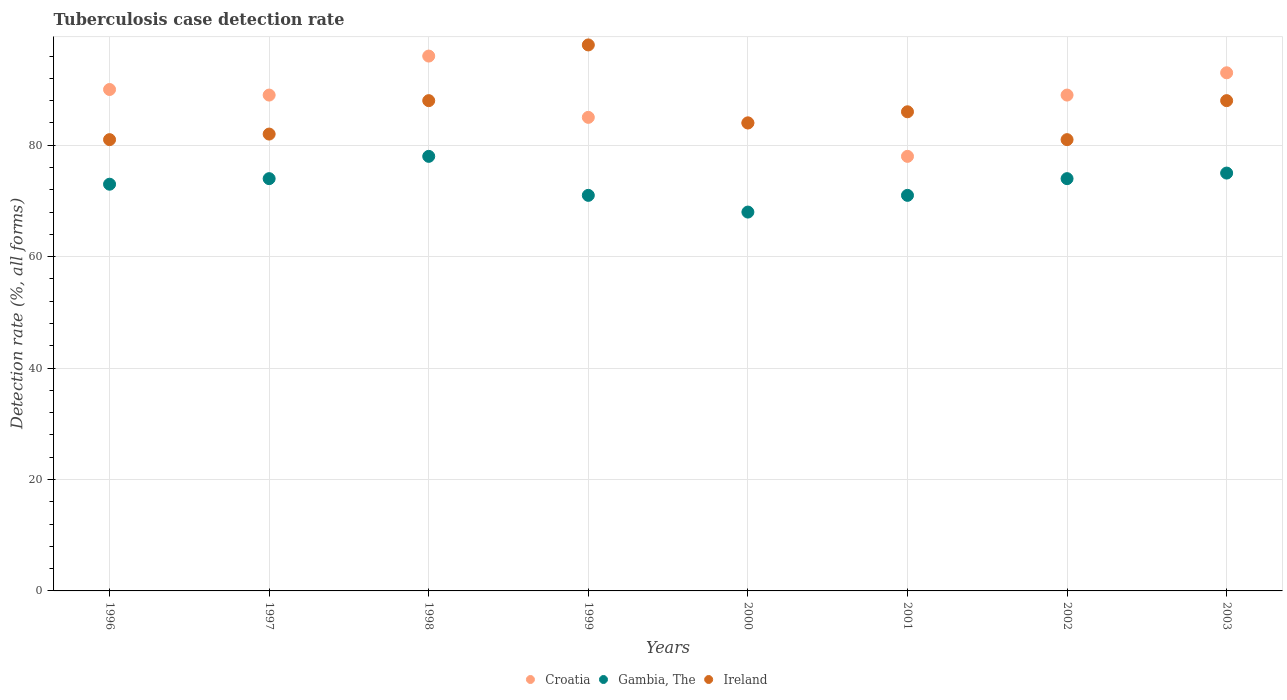Is the number of dotlines equal to the number of legend labels?
Provide a short and direct response. Yes. What is the tuberculosis case detection rate in in Gambia, The in 2000?
Ensure brevity in your answer.  68. Across all years, what is the maximum tuberculosis case detection rate in in Ireland?
Offer a very short reply. 98. Across all years, what is the minimum tuberculosis case detection rate in in Ireland?
Ensure brevity in your answer.  81. In which year was the tuberculosis case detection rate in in Croatia maximum?
Your answer should be compact. 1998. What is the total tuberculosis case detection rate in in Gambia, The in the graph?
Keep it short and to the point. 584. What is the difference between the tuberculosis case detection rate in in Ireland in 1998 and that in 2001?
Your answer should be compact. 2. What is the difference between the tuberculosis case detection rate in in Ireland in 1999 and the tuberculosis case detection rate in in Croatia in 2000?
Your answer should be very brief. 14. What is the average tuberculosis case detection rate in in Gambia, The per year?
Offer a terse response. 73. In the year 1998, what is the difference between the tuberculosis case detection rate in in Croatia and tuberculosis case detection rate in in Gambia, The?
Ensure brevity in your answer.  18. In how many years, is the tuberculosis case detection rate in in Ireland greater than 80 %?
Ensure brevity in your answer.  8. What is the ratio of the tuberculosis case detection rate in in Croatia in 1999 to that in 2002?
Make the answer very short. 0.96. Is the tuberculosis case detection rate in in Croatia in 1999 less than that in 2003?
Keep it short and to the point. Yes. In how many years, is the tuberculosis case detection rate in in Croatia greater than the average tuberculosis case detection rate in in Croatia taken over all years?
Provide a succinct answer. 5. Is the sum of the tuberculosis case detection rate in in Ireland in 1996 and 1999 greater than the maximum tuberculosis case detection rate in in Croatia across all years?
Your answer should be compact. Yes. What is the difference between two consecutive major ticks on the Y-axis?
Ensure brevity in your answer.  20. Are the values on the major ticks of Y-axis written in scientific E-notation?
Offer a terse response. No. Does the graph contain grids?
Offer a very short reply. Yes. Where does the legend appear in the graph?
Ensure brevity in your answer.  Bottom center. How many legend labels are there?
Offer a terse response. 3. What is the title of the graph?
Give a very brief answer. Tuberculosis case detection rate. Does "Brunei Darussalam" appear as one of the legend labels in the graph?
Give a very brief answer. No. What is the label or title of the X-axis?
Keep it short and to the point. Years. What is the label or title of the Y-axis?
Keep it short and to the point. Detection rate (%, all forms). What is the Detection rate (%, all forms) of Ireland in 1996?
Give a very brief answer. 81. What is the Detection rate (%, all forms) of Croatia in 1997?
Keep it short and to the point. 89. What is the Detection rate (%, all forms) of Gambia, The in 1997?
Make the answer very short. 74. What is the Detection rate (%, all forms) in Croatia in 1998?
Your response must be concise. 96. What is the Detection rate (%, all forms) of Gambia, The in 1998?
Make the answer very short. 78. What is the Detection rate (%, all forms) of Gambia, The in 1999?
Provide a short and direct response. 71. What is the Detection rate (%, all forms) in Croatia in 2001?
Ensure brevity in your answer.  78. What is the Detection rate (%, all forms) of Ireland in 2001?
Provide a succinct answer. 86. What is the Detection rate (%, all forms) of Croatia in 2002?
Your answer should be compact. 89. What is the Detection rate (%, all forms) in Ireland in 2002?
Ensure brevity in your answer.  81. What is the Detection rate (%, all forms) of Croatia in 2003?
Offer a terse response. 93. What is the Detection rate (%, all forms) of Ireland in 2003?
Your answer should be compact. 88. Across all years, what is the maximum Detection rate (%, all forms) of Croatia?
Your answer should be compact. 96. Across all years, what is the maximum Detection rate (%, all forms) of Gambia, The?
Keep it short and to the point. 78. Across all years, what is the maximum Detection rate (%, all forms) in Ireland?
Your answer should be very brief. 98. Across all years, what is the minimum Detection rate (%, all forms) of Gambia, The?
Your response must be concise. 68. What is the total Detection rate (%, all forms) in Croatia in the graph?
Keep it short and to the point. 704. What is the total Detection rate (%, all forms) of Gambia, The in the graph?
Ensure brevity in your answer.  584. What is the total Detection rate (%, all forms) of Ireland in the graph?
Provide a short and direct response. 688. What is the difference between the Detection rate (%, all forms) in Ireland in 1996 and that in 1998?
Ensure brevity in your answer.  -7. What is the difference between the Detection rate (%, all forms) of Gambia, The in 1996 and that in 1999?
Provide a succinct answer. 2. What is the difference between the Detection rate (%, all forms) of Ireland in 1996 and that in 2000?
Your answer should be compact. -3. What is the difference between the Detection rate (%, all forms) in Ireland in 1996 and that in 2001?
Provide a succinct answer. -5. What is the difference between the Detection rate (%, all forms) of Croatia in 1996 and that in 2002?
Provide a short and direct response. 1. What is the difference between the Detection rate (%, all forms) in Croatia in 1996 and that in 2003?
Ensure brevity in your answer.  -3. What is the difference between the Detection rate (%, all forms) in Ireland in 1996 and that in 2003?
Offer a terse response. -7. What is the difference between the Detection rate (%, all forms) in Croatia in 1997 and that in 1998?
Ensure brevity in your answer.  -7. What is the difference between the Detection rate (%, all forms) in Ireland in 1997 and that in 1998?
Ensure brevity in your answer.  -6. What is the difference between the Detection rate (%, all forms) of Croatia in 1997 and that in 2001?
Provide a succinct answer. 11. What is the difference between the Detection rate (%, all forms) in Gambia, The in 1997 and that in 2001?
Offer a very short reply. 3. What is the difference between the Detection rate (%, all forms) of Croatia in 1997 and that in 2002?
Your response must be concise. 0. What is the difference between the Detection rate (%, all forms) of Ireland in 1997 and that in 2002?
Give a very brief answer. 1. What is the difference between the Detection rate (%, all forms) in Croatia in 1997 and that in 2003?
Keep it short and to the point. -4. What is the difference between the Detection rate (%, all forms) in Gambia, The in 1997 and that in 2003?
Offer a terse response. -1. What is the difference between the Detection rate (%, all forms) in Ireland in 1997 and that in 2003?
Give a very brief answer. -6. What is the difference between the Detection rate (%, all forms) of Croatia in 1998 and that in 1999?
Keep it short and to the point. 11. What is the difference between the Detection rate (%, all forms) of Ireland in 1998 and that in 1999?
Offer a terse response. -10. What is the difference between the Detection rate (%, all forms) in Gambia, The in 1998 and that in 2001?
Your response must be concise. 7. What is the difference between the Detection rate (%, all forms) in Ireland in 1998 and that in 2001?
Give a very brief answer. 2. What is the difference between the Detection rate (%, all forms) in Gambia, The in 1999 and that in 2000?
Offer a very short reply. 3. What is the difference between the Detection rate (%, all forms) of Croatia in 1999 and that in 2001?
Your response must be concise. 7. What is the difference between the Detection rate (%, all forms) of Gambia, The in 1999 and that in 2001?
Give a very brief answer. 0. What is the difference between the Detection rate (%, all forms) in Ireland in 1999 and that in 2001?
Make the answer very short. 12. What is the difference between the Detection rate (%, all forms) of Croatia in 1999 and that in 2002?
Keep it short and to the point. -4. What is the difference between the Detection rate (%, all forms) of Croatia in 1999 and that in 2003?
Give a very brief answer. -8. What is the difference between the Detection rate (%, all forms) of Gambia, The in 2000 and that in 2001?
Give a very brief answer. -3. What is the difference between the Detection rate (%, all forms) of Ireland in 2000 and that in 2001?
Provide a short and direct response. -2. What is the difference between the Detection rate (%, all forms) of Gambia, The in 2000 and that in 2002?
Ensure brevity in your answer.  -6. What is the difference between the Detection rate (%, all forms) in Croatia in 2000 and that in 2003?
Provide a succinct answer. -9. What is the difference between the Detection rate (%, all forms) in Ireland in 2000 and that in 2003?
Keep it short and to the point. -4. What is the difference between the Detection rate (%, all forms) in Ireland in 2001 and that in 2002?
Your response must be concise. 5. What is the difference between the Detection rate (%, all forms) of Croatia in 2001 and that in 2003?
Provide a succinct answer. -15. What is the difference between the Detection rate (%, all forms) of Ireland in 2001 and that in 2003?
Provide a short and direct response. -2. What is the difference between the Detection rate (%, all forms) in Croatia in 1996 and the Detection rate (%, all forms) in Ireland in 1997?
Offer a very short reply. 8. What is the difference between the Detection rate (%, all forms) in Gambia, The in 1996 and the Detection rate (%, all forms) in Ireland in 1997?
Ensure brevity in your answer.  -9. What is the difference between the Detection rate (%, all forms) of Croatia in 1996 and the Detection rate (%, all forms) of Ireland in 1999?
Give a very brief answer. -8. What is the difference between the Detection rate (%, all forms) in Croatia in 1996 and the Detection rate (%, all forms) in Ireland in 2000?
Your answer should be compact. 6. What is the difference between the Detection rate (%, all forms) of Gambia, The in 1996 and the Detection rate (%, all forms) of Ireland in 2001?
Give a very brief answer. -13. What is the difference between the Detection rate (%, all forms) of Croatia in 1996 and the Detection rate (%, all forms) of Ireland in 2002?
Offer a very short reply. 9. What is the difference between the Detection rate (%, all forms) in Gambia, The in 1996 and the Detection rate (%, all forms) in Ireland in 2002?
Provide a succinct answer. -8. What is the difference between the Detection rate (%, all forms) in Croatia in 1996 and the Detection rate (%, all forms) in Ireland in 2003?
Offer a terse response. 2. What is the difference between the Detection rate (%, all forms) of Croatia in 1997 and the Detection rate (%, all forms) of Gambia, The in 1998?
Offer a terse response. 11. What is the difference between the Detection rate (%, all forms) in Croatia in 1997 and the Detection rate (%, all forms) in Ireland in 1998?
Your answer should be compact. 1. What is the difference between the Detection rate (%, all forms) of Gambia, The in 1997 and the Detection rate (%, all forms) of Ireland in 1998?
Your response must be concise. -14. What is the difference between the Detection rate (%, all forms) in Croatia in 1997 and the Detection rate (%, all forms) in Ireland in 1999?
Provide a short and direct response. -9. What is the difference between the Detection rate (%, all forms) in Gambia, The in 1997 and the Detection rate (%, all forms) in Ireland in 1999?
Give a very brief answer. -24. What is the difference between the Detection rate (%, all forms) in Croatia in 1997 and the Detection rate (%, all forms) in Gambia, The in 2000?
Offer a very short reply. 21. What is the difference between the Detection rate (%, all forms) of Croatia in 1997 and the Detection rate (%, all forms) of Ireland in 2000?
Provide a succinct answer. 5. What is the difference between the Detection rate (%, all forms) in Gambia, The in 1997 and the Detection rate (%, all forms) in Ireland in 2000?
Provide a short and direct response. -10. What is the difference between the Detection rate (%, all forms) in Croatia in 1997 and the Detection rate (%, all forms) in Gambia, The in 2001?
Provide a short and direct response. 18. What is the difference between the Detection rate (%, all forms) in Croatia in 1997 and the Detection rate (%, all forms) in Ireland in 2001?
Your answer should be compact. 3. What is the difference between the Detection rate (%, all forms) of Croatia in 1997 and the Detection rate (%, all forms) of Gambia, The in 2002?
Keep it short and to the point. 15. What is the difference between the Detection rate (%, all forms) of Croatia in 1997 and the Detection rate (%, all forms) of Ireland in 2002?
Give a very brief answer. 8. What is the difference between the Detection rate (%, all forms) in Gambia, The in 1997 and the Detection rate (%, all forms) in Ireland in 2002?
Offer a very short reply. -7. What is the difference between the Detection rate (%, all forms) in Croatia in 1998 and the Detection rate (%, all forms) in Gambia, The in 1999?
Provide a succinct answer. 25. What is the difference between the Detection rate (%, all forms) of Croatia in 1998 and the Detection rate (%, all forms) of Ireland in 2000?
Provide a succinct answer. 12. What is the difference between the Detection rate (%, all forms) of Gambia, The in 1998 and the Detection rate (%, all forms) of Ireland in 2000?
Give a very brief answer. -6. What is the difference between the Detection rate (%, all forms) in Croatia in 1998 and the Detection rate (%, all forms) in Ireland in 2001?
Your answer should be compact. 10. What is the difference between the Detection rate (%, all forms) in Gambia, The in 1998 and the Detection rate (%, all forms) in Ireland in 2001?
Give a very brief answer. -8. What is the difference between the Detection rate (%, all forms) in Croatia in 1998 and the Detection rate (%, all forms) in Ireland in 2002?
Provide a succinct answer. 15. What is the difference between the Detection rate (%, all forms) in Gambia, The in 1998 and the Detection rate (%, all forms) in Ireland in 2002?
Offer a very short reply. -3. What is the difference between the Detection rate (%, all forms) of Croatia in 1998 and the Detection rate (%, all forms) of Gambia, The in 2003?
Your answer should be very brief. 21. What is the difference between the Detection rate (%, all forms) in Gambia, The in 1998 and the Detection rate (%, all forms) in Ireland in 2003?
Offer a very short reply. -10. What is the difference between the Detection rate (%, all forms) in Croatia in 1999 and the Detection rate (%, all forms) in Gambia, The in 2000?
Ensure brevity in your answer.  17. What is the difference between the Detection rate (%, all forms) of Gambia, The in 1999 and the Detection rate (%, all forms) of Ireland in 2001?
Give a very brief answer. -15. What is the difference between the Detection rate (%, all forms) of Croatia in 1999 and the Detection rate (%, all forms) of Gambia, The in 2002?
Give a very brief answer. 11. What is the difference between the Detection rate (%, all forms) of Croatia in 1999 and the Detection rate (%, all forms) of Ireland in 2002?
Keep it short and to the point. 4. What is the difference between the Detection rate (%, all forms) of Croatia in 1999 and the Detection rate (%, all forms) of Gambia, The in 2003?
Your answer should be compact. 10. What is the difference between the Detection rate (%, all forms) of Gambia, The in 1999 and the Detection rate (%, all forms) of Ireland in 2003?
Give a very brief answer. -17. What is the difference between the Detection rate (%, all forms) of Croatia in 2000 and the Detection rate (%, all forms) of Gambia, The in 2001?
Give a very brief answer. 13. What is the difference between the Detection rate (%, all forms) in Gambia, The in 2000 and the Detection rate (%, all forms) in Ireland in 2001?
Give a very brief answer. -18. What is the difference between the Detection rate (%, all forms) of Croatia in 2000 and the Detection rate (%, all forms) of Ireland in 2002?
Give a very brief answer. 3. What is the difference between the Detection rate (%, all forms) in Croatia in 2001 and the Detection rate (%, all forms) in Gambia, The in 2002?
Make the answer very short. 4. What is the difference between the Detection rate (%, all forms) of Croatia in 2001 and the Detection rate (%, all forms) of Ireland in 2002?
Offer a very short reply. -3. What is the difference between the Detection rate (%, all forms) in Croatia in 2001 and the Detection rate (%, all forms) in Gambia, The in 2003?
Give a very brief answer. 3. What is the difference between the Detection rate (%, all forms) in Gambia, The in 2002 and the Detection rate (%, all forms) in Ireland in 2003?
Provide a succinct answer. -14. What is the average Detection rate (%, all forms) of Ireland per year?
Give a very brief answer. 86. In the year 1996, what is the difference between the Detection rate (%, all forms) in Croatia and Detection rate (%, all forms) in Gambia, The?
Offer a very short reply. 17. In the year 1996, what is the difference between the Detection rate (%, all forms) of Croatia and Detection rate (%, all forms) of Ireland?
Offer a terse response. 9. In the year 1997, what is the difference between the Detection rate (%, all forms) of Croatia and Detection rate (%, all forms) of Ireland?
Offer a very short reply. 7. In the year 1997, what is the difference between the Detection rate (%, all forms) of Gambia, The and Detection rate (%, all forms) of Ireland?
Keep it short and to the point. -8. In the year 1999, what is the difference between the Detection rate (%, all forms) of Gambia, The and Detection rate (%, all forms) of Ireland?
Your answer should be compact. -27. In the year 2000, what is the difference between the Detection rate (%, all forms) of Croatia and Detection rate (%, all forms) of Ireland?
Ensure brevity in your answer.  0. In the year 2000, what is the difference between the Detection rate (%, all forms) of Gambia, The and Detection rate (%, all forms) of Ireland?
Offer a very short reply. -16. In the year 2001, what is the difference between the Detection rate (%, all forms) of Croatia and Detection rate (%, all forms) of Ireland?
Ensure brevity in your answer.  -8. In the year 2001, what is the difference between the Detection rate (%, all forms) of Gambia, The and Detection rate (%, all forms) of Ireland?
Offer a very short reply. -15. In the year 2002, what is the difference between the Detection rate (%, all forms) in Croatia and Detection rate (%, all forms) in Ireland?
Your answer should be very brief. 8. In the year 2002, what is the difference between the Detection rate (%, all forms) of Gambia, The and Detection rate (%, all forms) of Ireland?
Your response must be concise. -7. What is the ratio of the Detection rate (%, all forms) of Croatia in 1996 to that in 1997?
Ensure brevity in your answer.  1.01. What is the ratio of the Detection rate (%, all forms) of Gambia, The in 1996 to that in 1997?
Offer a very short reply. 0.99. What is the ratio of the Detection rate (%, all forms) of Gambia, The in 1996 to that in 1998?
Provide a succinct answer. 0.94. What is the ratio of the Detection rate (%, all forms) of Ireland in 1996 to that in 1998?
Offer a terse response. 0.92. What is the ratio of the Detection rate (%, all forms) in Croatia in 1996 to that in 1999?
Your answer should be compact. 1.06. What is the ratio of the Detection rate (%, all forms) of Gambia, The in 1996 to that in 1999?
Provide a short and direct response. 1.03. What is the ratio of the Detection rate (%, all forms) in Ireland in 1996 to that in 1999?
Ensure brevity in your answer.  0.83. What is the ratio of the Detection rate (%, all forms) in Croatia in 1996 to that in 2000?
Provide a succinct answer. 1.07. What is the ratio of the Detection rate (%, all forms) in Gambia, The in 1996 to that in 2000?
Your response must be concise. 1.07. What is the ratio of the Detection rate (%, all forms) of Croatia in 1996 to that in 2001?
Make the answer very short. 1.15. What is the ratio of the Detection rate (%, all forms) in Gambia, The in 1996 to that in 2001?
Provide a short and direct response. 1.03. What is the ratio of the Detection rate (%, all forms) in Ireland in 1996 to that in 2001?
Offer a very short reply. 0.94. What is the ratio of the Detection rate (%, all forms) in Croatia in 1996 to that in 2002?
Your response must be concise. 1.01. What is the ratio of the Detection rate (%, all forms) of Gambia, The in 1996 to that in 2002?
Provide a succinct answer. 0.99. What is the ratio of the Detection rate (%, all forms) of Croatia in 1996 to that in 2003?
Ensure brevity in your answer.  0.97. What is the ratio of the Detection rate (%, all forms) of Gambia, The in 1996 to that in 2003?
Make the answer very short. 0.97. What is the ratio of the Detection rate (%, all forms) in Ireland in 1996 to that in 2003?
Provide a succinct answer. 0.92. What is the ratio of the Detection rate (%, all forms) of Croatia in 1997 to that in 1998?
Your answer should be compact. 0.93. What is the ratio of the Detection rate (%, all forms) of Gambia, The in 1997 to that in 1998?
Provide a succinct answer. 0.95. What is the ratio of the Detection rate (%, all forms) in Ireland in 1997 to that in 1998?
Offer a very short reply. 0.93. What is the ratio of the Detection rate (%, all forms) of Croatia in 1997 to that in 1999?
Offer a very short reply. 1.05. What is the ratio of the Detection rate (%, all forms) in Gambia, The in 1997 to that in 1999?
Provide a succinct answer. 1.04. What is the ratio of the Detection rate (%, all forms) of Ireland in 1997 to that in 1999?
Make the answer very short. 0.84. What is the ratio of the Detection rate (%, all forms) of Croatia in 1997 to that in 2000?
Your answer should be very brief. 1.06. What is the ratio of the Detection rate (%, all forms) in Gambia, The in 1997 to that in 2000?
Provide a succinct answer. 1.09. What is the ratio of the Detection rate (%, all forms) in Ireland in 1997 to that in 2000?
Ensure brevity in your answer.  0.98. What is the ratio of the Detection rate (%, all forms) in Croatia in 1997 to that in 2001?
Offer a very short reply. 1.14. What is the ratio of the Detection rate (%, all forms) in Gambia, The in 1997 to that in 2001?
Provide a succinct answer. 1.04. What is the ratio of the Detection rate (%, all forms) of Ireland in 1997 to that in 2001?
Ensure brevity in your answer.  0.95. What is the ratio of the Detection rate (%, all forms) in Ireland in 1997 to that in 2002?
Offer a terse response. 1.01. What is the ratio of the Detection rate (%, all forms) in Gambia, The in 1997 to that in 2003?
Your response must be concise. 0.99. What is the ratio of the Detection rate (%, all forms) in Ireland in 1997 to that in 2003?
Provide a short and direct response. 0.93. What is the ratio of the Detection rate (%, all forms) in Croatia in 1998 to that in 1999?
Provide a succinct answer. 1.13. What is the ratio of the Detection rate (%, all forms) in Gambia, The in 1998 to that in 1999?
Make the answer very short. 1.1. What is the ratio of the Detection rate (%, all forms) of Ireland in 1998 to that in 1999?
Your answer should be compact. 0.9. What is the ratio of the Detection rate (%, all forms) of Croatia in 1998 to that in 2000?
Your response must be concise. 1.14. What is the ratio of the Detection rate (%, all forms) in Gambia, The in 1998 to that in 2000?
Provide a short and direct response. 1.15. What is the ratio of the Detection rate (%, all forms) in Ireland in 1998 to that in 2000?
Your response must be concise. 1.05. What is the ratio of the Detection rate (%, all forms) of Croatia in 1998 to that in 2001?
Keep it short and to the point. 1.23. What is the ratio of the Detection rate (%, all forms) in Gambia, The in 1998 to that in 2001?
Provide a short and direct response. 1.1. What is the ratio of the Detection rate (%, all forms) in Ireland in 1998 to that in 2001?
Keep it short and to the point. 1.02. What is the ratio of the Detection rate (%, all forms) of Croatia in 1998 to that in 2002?
Offer a very short reply. 1.08. What is the ratio of the Detection rate (%, all forms) in Gambia, The in 1998 to that in 2002?
Provide a succinct answer. 1.05. What is the ratio of the Detection rate (%, all forms) in Ireland in 1998 to that in 2002?
Make the answer very short. 1.09. What is the ratio of the Detection rate (%, all forms) of Croatia in 1998 to that in 2003?
Offer a very short reply. 1.03. What is the ratio of the Detection rate (%, all forms) in Gambia, The in 1998 to that in 2003?
Ensure brevity in your answer.  1.04. What is the ratio of the Detection rate (%, all forms) of Croatia in 1999 to that in 2000?
Make the answer very short. 1.01. What is the ratio of the Detection rate (%, all forms) in Gambia, The in 1999 to that in 2000?
Provide a short and direct response. 1.04. What is the ratio of the Detection rate (%, all forms) of Croatia in 1999 to that in 2001?
Offer a terse response. 1.09. What is the ratio of the Detection rate (%, all forms) of Gambia, The in 1999 to that in 2001?
Your answer should be compact. 1. What is the ratio of the Detection rate (%, all forms) in Ireland in 1999 to that in 2001?
Give a very brief answer. 1.14. What is the ratio of the Detection rate (%, all forms) of Croatia in 1999 to that in 2002?
Your answer should be compact. 0.96. What is the ratio of the Detection rate (%, all forms) of Gambia, The in 1999 to that in 2002?
Your answer should be compact. 0.96. What is the ratio of the Detection rate (%, all forms) in Ireland in 1999 to that in 2002?
Make the answer very short. 1.21. What is the ratio of the Detection rate (%, all forms) in Croatia in 1999 to that in 2003?
Give a very brief answer. 0.91. What is the ratio of the Detection rate (%, all forms) of Gambia, The in 1999 to that in 2003?
Your answer should be very brief. 0.95. What is the ratio of the Detection rate (%, all forms) in Ireland in 1999 to that in 2003?
Your response must be concise. 1.11. What is the ratio of the Detection rate (%, all forms) in Croatia in 2000 to that in 2001?
Keep it short and to the point. 1.08. What is the ratio of the Detection rate (%, all forms) of Gambia, The in 2000 to that in 2001?
Ensure brevity in your answer.  0.96. What is the ratio of the Detection rate (%, all forms) in Ireland in 2000 to that in 2001?
Your answer should be very brief. 0.98. What is the ratio of the Detection rate (%, all forms) in Croatia in 2000 to that in 2002?
Make the answer very short. 0.94. What is the ratio of the Detection rate (%, all forms) of Gambia, The in 2000 to that in 2002?
Keep it short and to the point. 0.92. What is the ratio of the Detection rate (%, all forms) of Ireland in 2000 to that in 2002?
Make the answer very short. 1.04. What is the ratio of the Detection rate (%, all forms) in Croatia in 2000 to that in 2003?
Your answer should be compact. 0.9. What is the ratio of the Detection rate (%, all forms) of Gambia, The in 2000 to that in 2003?
Ensure brevity in your answer.  0.91. What is the ratio of the Detection rate (%, all forms) of Ireland in 2000 to that in 2003?
Your answer should be very brief. 0.95. What is the ratio of the Detection rate (%, all forms) in Croatia in 2001 to that in 2002?
Your answer should be compact. 0.88. What is the ratio of the Detection rate (%, all forms) in Gambia, The in 2001 to that in 2002?
Make the answer very short. 0.96. What is the ratio of the Detection rate (%, all forms) of Ireland in 2001 to that in 2002?
Provide a short and direct response. 1.06. What is the ratio of the Detection rate (%, all forms) in Croatia in 2001 to that in 2003?
Your answer should be very brief. 0.84. What is the ratio of the Detection rate (%, all forms) of Gambia, The in 2001 to that in 2003?
Your answer should be very brief. 0.95. What is the ratio of the Detection rate (%, all forms) of Ireland in 2001 to that in 2003?
Your response must be concise. 0.98. What is the ratio of the Detection rate (%, all forms) of Gambia, The in 2002 to that in 2003?
Give a very brief answer. 0.99. What is the ratio of the Detection rate (%, all forms) of Ireland in 2002 to that in 2003?
Provide a succinct answer. 0.92. What is the difference between the highest and the second highest Detection rate (%, all forms) in Croatia?
Ensure brevity in your answer.  3. What is the difference between the highest and the second highest Detection rate (%, all forms) in Ireland?
Your response must be concise. 10. What is the difference between the highest and the lowest Detection rate (%, all forms) in Croatia?
Offer a very short reply. 18. 